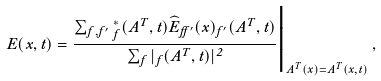<formula> <loc_0><loc_0><loc_500><loc_500>E ( { x } , t ) = \frac { \sum _ { f , f ^ { \prime } } \Psi ^ { * } _ { f } ( { A } ^ { T } , t ) { \widehat { E } } _ { f f ^ { \prime } } ( { x } ) \Psi _ { f ^ { \prime } } ( { A } ^ { T } , t ) } { \sum _ { f } | \Psi _ { f } ( { A } ^ { T } , t ) | ^ { 2 } } \Big | _ { { A } ^ { T } ( { x } ) = { A } ^ { T } ( { x } , t ) } \, ,</formula> 